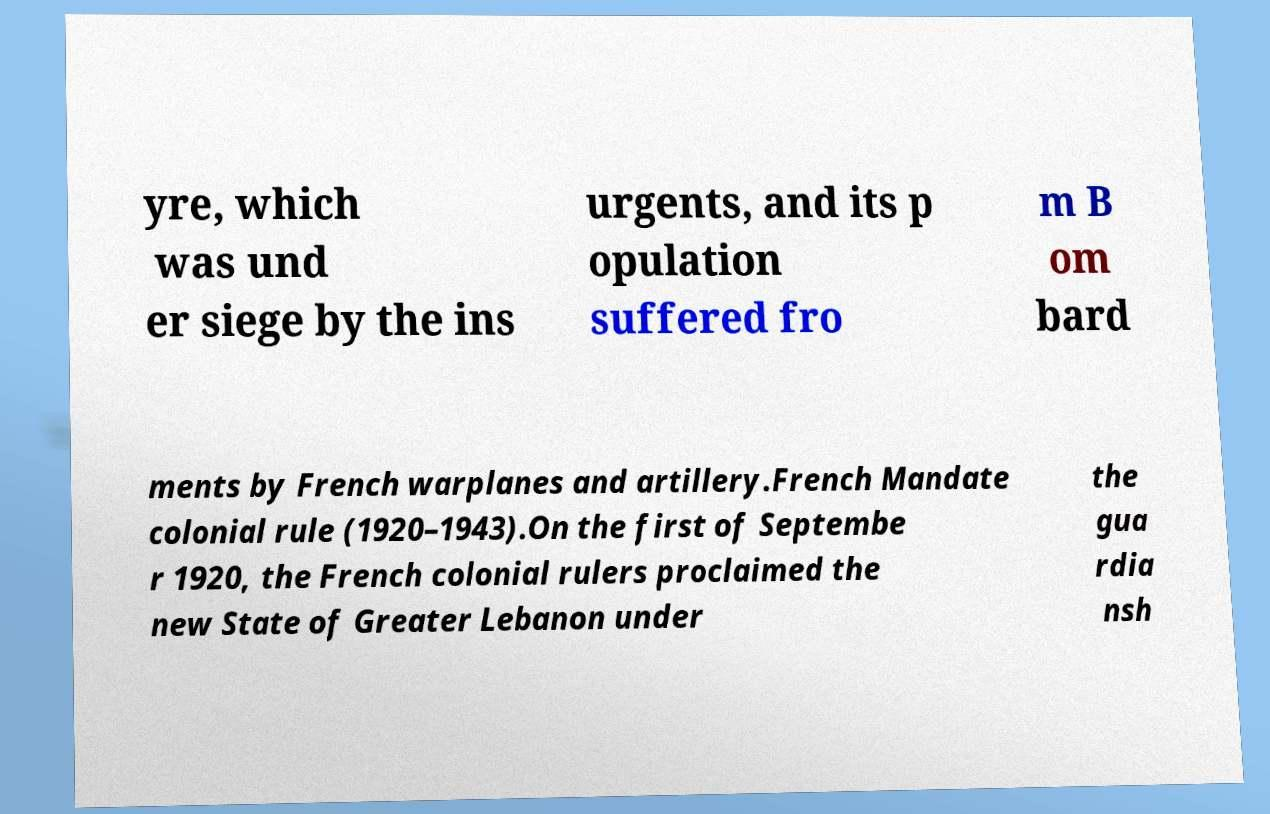Could you extract and type out the text from this image? yre, which was und er siege by the ins urgents, and its p opulation suffered fro m B om bard ments by French warplanes and artillery.French Mandate colonial rule (1920–1943).On the first of Septembe r 1920, the French colonial rulers proclaimed the new State of Greater Lebanon under the gua rdia nsh 